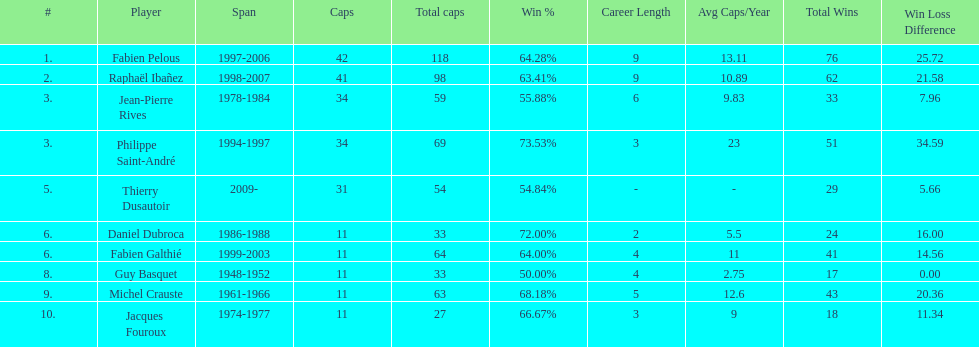What was the total number of caps earned by guy basquet throughout his career? 33. 